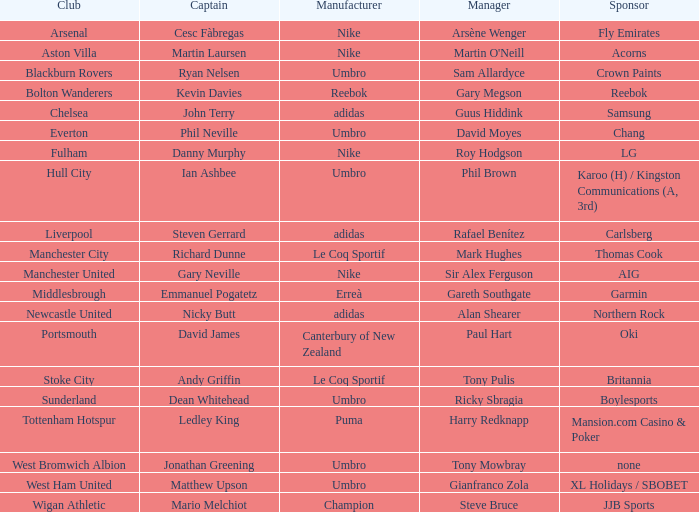Which Manchester United captain is sponsored by Nike? Gary Neville. Write the full table. {'header': ['Club', 'Captain', 'Manufacturer', 'Manager', 'Sponsor'], 'rows': [['Arsenal', 'Cesc Fàbregas', 'Nike', 'Arsène Wenger', 'Fly Emirates'], ['Aston Villa', 'Martin Laursen', 'Nike', "Martin O'Neill", 'Acorns'], ['Blackburn Rovers', 'Ryan Nelsen', 'Umbro', 'Sam Allardyce', 'Crown Paints'], ['Bolton Wanderers', 'Kevin Davies', 'Reebok', 'Gary Megson', 'Reebok'], ['Chelsea', 'John Terry', 'adidas', 'Guus Hiddink', 'Samsung'], ['Everton', 'Phil Neville', 'Umbro', 'David Moyes', 'Chang'], ['Fulham', 'Danny Murphy', 'Nike', 'Roy Hodgson', 'LG'], ['Hull City', 'Ian Ashbee', 'Umbro', 'Phil Brown', 'Karoo (H) / Kingston Communications (A, 3rd)'], ['Liverpool', 'Steven Gerrard', 'adidas', 'Rafael Benítez', 'Carlsberg'], ['Manchester City', 'Richard Dunne', 'Le Coq Sportif', 'Mark Hughes', 'Thomas Cook'], ['Manchester United', 'Gary Neville', 'Nike', 'Sir Alex Ferguson', 'AIG'], ['Middlesbrough', 'Emmanuel Pogatetz', 'Erreà', 'Gareth Southgate', 'Garmin'], ['Newcastle United', 'Nicky Butt', 'adidas', 'Alan Shearer', 'Northern Rock'], ['Portsmouth', 'David James', 'Canterbury of New Zealand', 'Paul Hart', 'Oki'], ['Stoke City', 'Andy Griffin', 'Le Coq Sportif', 'Tony Pulis', 'Britannia'], ['Sunderland', 'Dean Whitehead', 'Umbro', 'Ricky Sbragia', 'Boylesports'], ['Tottenham Hotspur', 'Ledley King', 'Puma', 'Harry Redknapp', 'Mansion.com Casino & Poker'], ['West Bromwich Albion', 'Jonathan Greening', 'Umbro', 'Tony Mowbray', 'none'], ['West Ham United', 'Matthew Upson', 'Umbro', 'Gianfranco Zola', 'XL Holidays / SBOBET'], ['Wigan Athletic', 'Mario Melchiot', 'Champion', 'Steve Bruce', 'JJB Sports']]} 